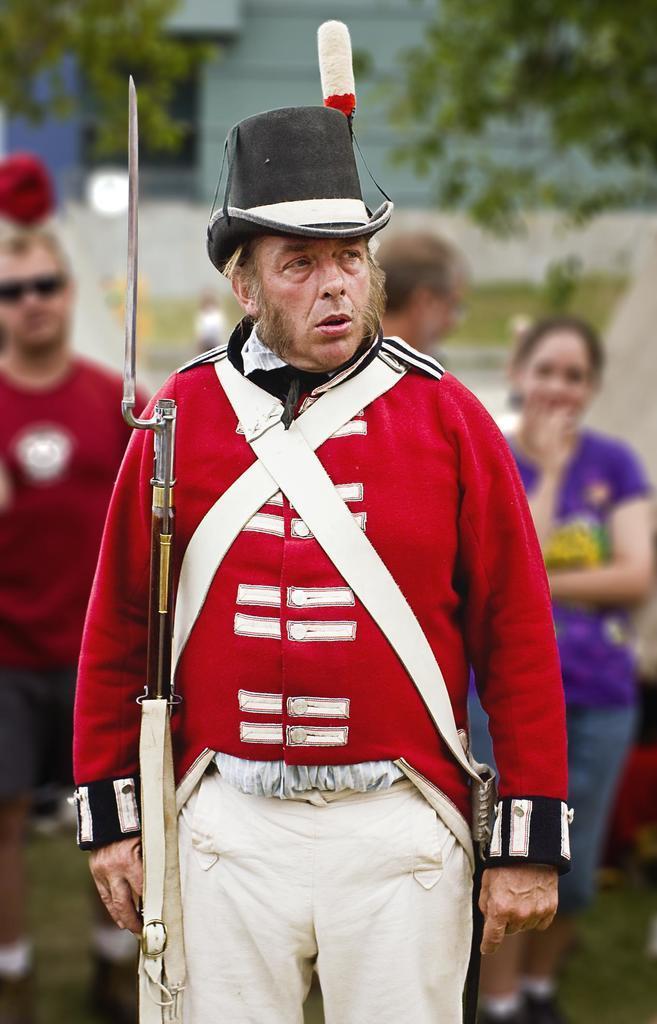Please provide a concise description of this image. In this image there is a person wearing a red color uniform is standing and he is holding a gun in his hand. He is wearing a hat. Behind him there are few persons standing on the grass land. Left side there is a person wearing a red T-shirt is having goggles. Right side there is a woman wearing blue top is standing on the grass land. Behind them there is a few trees. Behind it there is a building. 